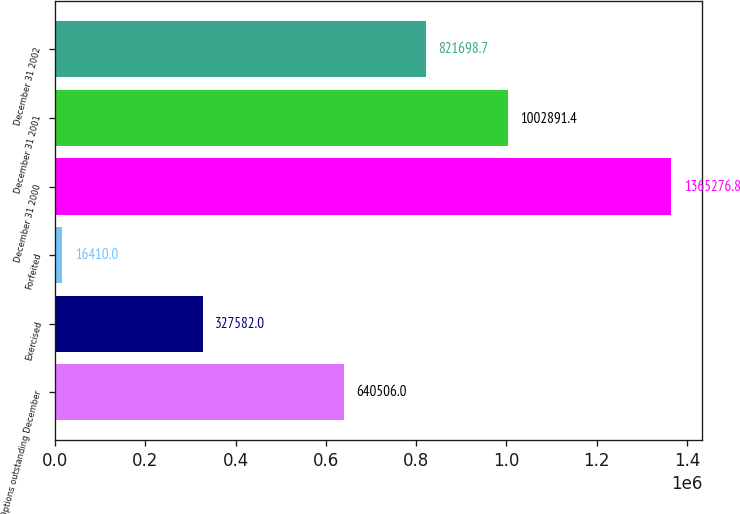<chart> <loc_0><loc_0><loc_500><loc_500><bar_chart><fcel>Options outstanding December<fcel>Exercised<fcel>Forfeited<fcel>December 31 2000<fcel>December 31 2001<fcel>December 31 2002<nl><fcel>640506<fcel>327582<fcel>16410<fcel>1.36528e+06<fcel>1.00289e+06<fcel>821699<nl></chart> 